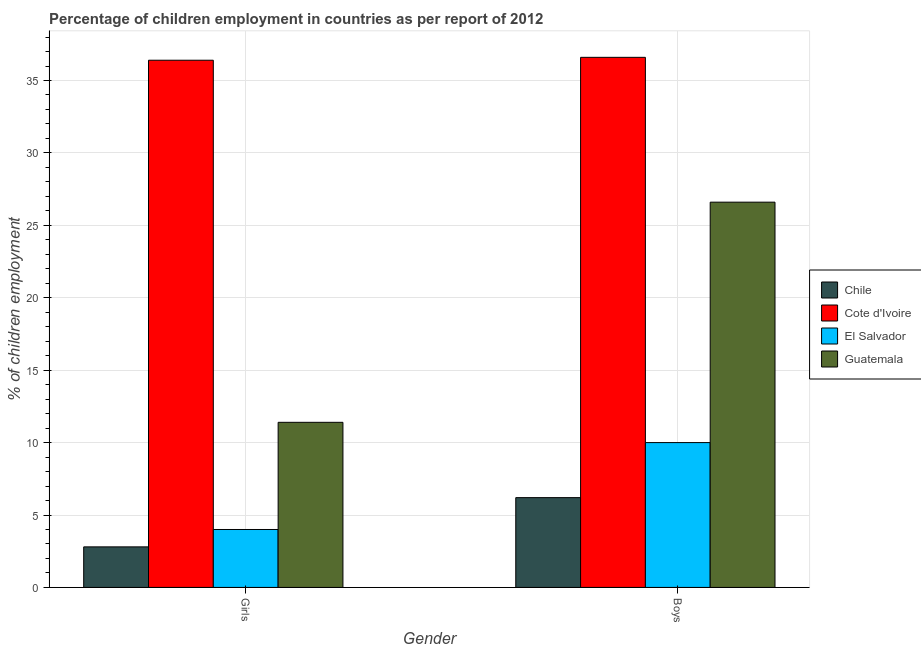How many groups of bars are there?
Provide a succinct answer. 2. How many bars are there on the 1st tick from the right?
Provide a succinct answer. 4. What is the label of the 1st group of bars from the left?
Your response must be concise. Girls. Across all countries, what is the maximum percentage of employed girls?
Your answer should be very brief. 36.4. In which country was the percentage of employed boys maximum?
Make the answer very short. Cote d'Ivoire. In which country was the percentage of employed boys minimum?
Keep it short and to the point. Chile. What is the total percentage of employed boys in the graph?
Provide a short and direct response. 79.4. What is the difference between the percentage of employed boys in Chile and that in Cote d'Ivoire?
Your answer should be very brief. -30.4. What is the difference between the percentage of employed boys in Chile and the percentage of employed girls in Guatemala?
Make the answer very short. -5.2. What is the average percentage of employed boys per country?
Make the answer very short. 19.85. What is the difference between the percentage of employed boys and percentage of employed girls in Cote d'Ivoire?
Offer a terse response. 0.2. What is the ratio of the percentage of employed girls in Chile to that in Guatemala?
Your response must be concise. 0.25. What does the 3rd bar from the left in Boys represents?
Give a very brief answer. El Salvador. What does the 4th bar from the right in Boys represents?
Your response must be concise. Chile. Are all the bars in the graph horizontal?
Provide a short and direct response. No. What is the difference between two consecutive major ticks on the Y-axis?
Your answer should be very brief. 5. Does the graph contain grids?
Your answer should be compact. Yes. What is the title of the graph?
Your answer should be compact. Percentage of children employment in countries as per report of 2012. Does "Tuvalu" appear as one of the legend labels in the graph?
Your answer should be compact. No. What is the label or title of the X-axis?
Make the answer very short. Gender. What is the label or title of the Y-axis?
Provide a succinct answer. % of children employment. What is the % of children employment of Chile in Girls?
Your answer should be compact. 2.8. What is the % of children employment in Cote d'Ivoire in Girls?
Give a very brief answer. 36.4. What is the % of children employment in El Salvador in Girls?
Ensure brevity in your answer.  4. What is the % of children employment in Guatemala in Girls?
Your answer should be very brief. 11.4. What is the % of children employment in Cote d'Ivoire in Boys?
Give a very brief answer. 36.6. What is the % of children employment of Guatemala in Boys?
Provide a succinct answer. 26.6. Across all Gender, what is the maximum % of children employment in Chile?
Your response must be concise. 6.2. Across all Gender, what is the maximum % of children employment of Cote d'Ivoire?
Your answer should be very brief. 36.6. Across all Gender, what is the maximum % of children employment of Guatemala?
Provide a short and direct response. 26.6. Across all Gender, what is the minimum % of children employment of Chile?
Provide a short and direct response. 2.8. Across all Gender, what is the minimum % of children employment in Cote d'Ivoire?
Your answer should be compact. 36.4. Across all Gender, what is the minimum % of children employment of El Salvador?
Offer a very short reply. 4. What is the difference between the % of children employment in Chile in Girls and that in Boys?
Provide a succinct answer. -3.4. What is the difference between the % of children employment in Cote d'Ivoire in Girls and that in Boys?
Your response must be concise. -0.2. What is the difference between the % of children employment in El Salvador in Girls and that in Boys?
Offer a very short reply. -6. What is the difference between the % of children employment in Guatemala in Girls and that in Boys?
Offer a very short reply. -15.2. What is the difference between the % of children employment of Chile in Girls and the % of children employment of Cote d'Ivoire in Boys?
Your answer should be compact. -33.8. What is the difference between the % of children employment of Chile in Girls and the % of children employment of El Salvador in Boys?
Provide a short and direct response. -7.2. What is the difference between the % of children employment of Chile in Girls and the % of children employment of Guatemala in Boys?
Ensure brevity in your answer.  -23.8. What is the difference between the % of children employment in Cote d'Ivoire in Girls and the % of children employment in El Salvador in Boys?
Provide a succinct answer. 26.4. What is the difference between the % of children employment of El Salvador in Girls and the % of children employment of Guatemala in Boys?
Your answer should be very brief. -22.6. What is the average % of children employment in Chile per Gender?
Your answer should be very brief. 4.5. What is the average % of children employment of Cote d'Ivoire per Gender?
Offer a very short reply. 36.5. What is the difference between the % of children employment of Chile and % of children employment of Cote d'Ivoire in Girls?
Provide a short and direct response. -33.6. What is the difference between the % of children employment of Cote d'Ivoire and % of children employment of El Salvador in Girls?
Offer a very short reply. 32.4. What is the difference between the % of children employment in Cote d'Ivoire and % of children employment in Guatemala in Girls?
Give a very brief answer. 25. What is the difference between the % of children employment of Chile and % of children employment of Cote d'Ivoire in Boys?
Provide a succinct answer. -30.4. What is the difference between the % of children employment in Chile and % of children employment in Guatemala in Boys?
Ensure brevity in your answer.  -20.4. What is the difference between the % of children employment in Cote d'Ivoire and % of children employment in El Salvador in Boys?
Provide a succinct answer. 26.6. What is the difference between the % of children employment in El Salvador and % of children employment in Guatemala in Boys?
Provide a short and direct response. -16.6. What is the ratio of the % of children employment in Chile in Girls to that in Boys?
Offer a very short reply. 0.45. What is the ratio of the % of children employment of Guatemala in Girls to that in Boys?
Provide a short and direct response. 0.43. What is the difference between the highest and the second highest % of children employment of Cote d'Ivoire?
Give a very brief answer. 0.2. What is the difference between the highest and the second highest % of children employment in El Salvador?
Keep it short and to the point. 6. What is the difference between the highest and the second highest % of children employment of Guatemala?
Your answer should be compact. 15.2. What is the difference between the highest and the lowest % of children employment of El Salvador?
Provide a succinct answer. 6. What is the difference between the highest and the lowest % of children employment of Guatemala?
Your response must be concise. 15.2. 